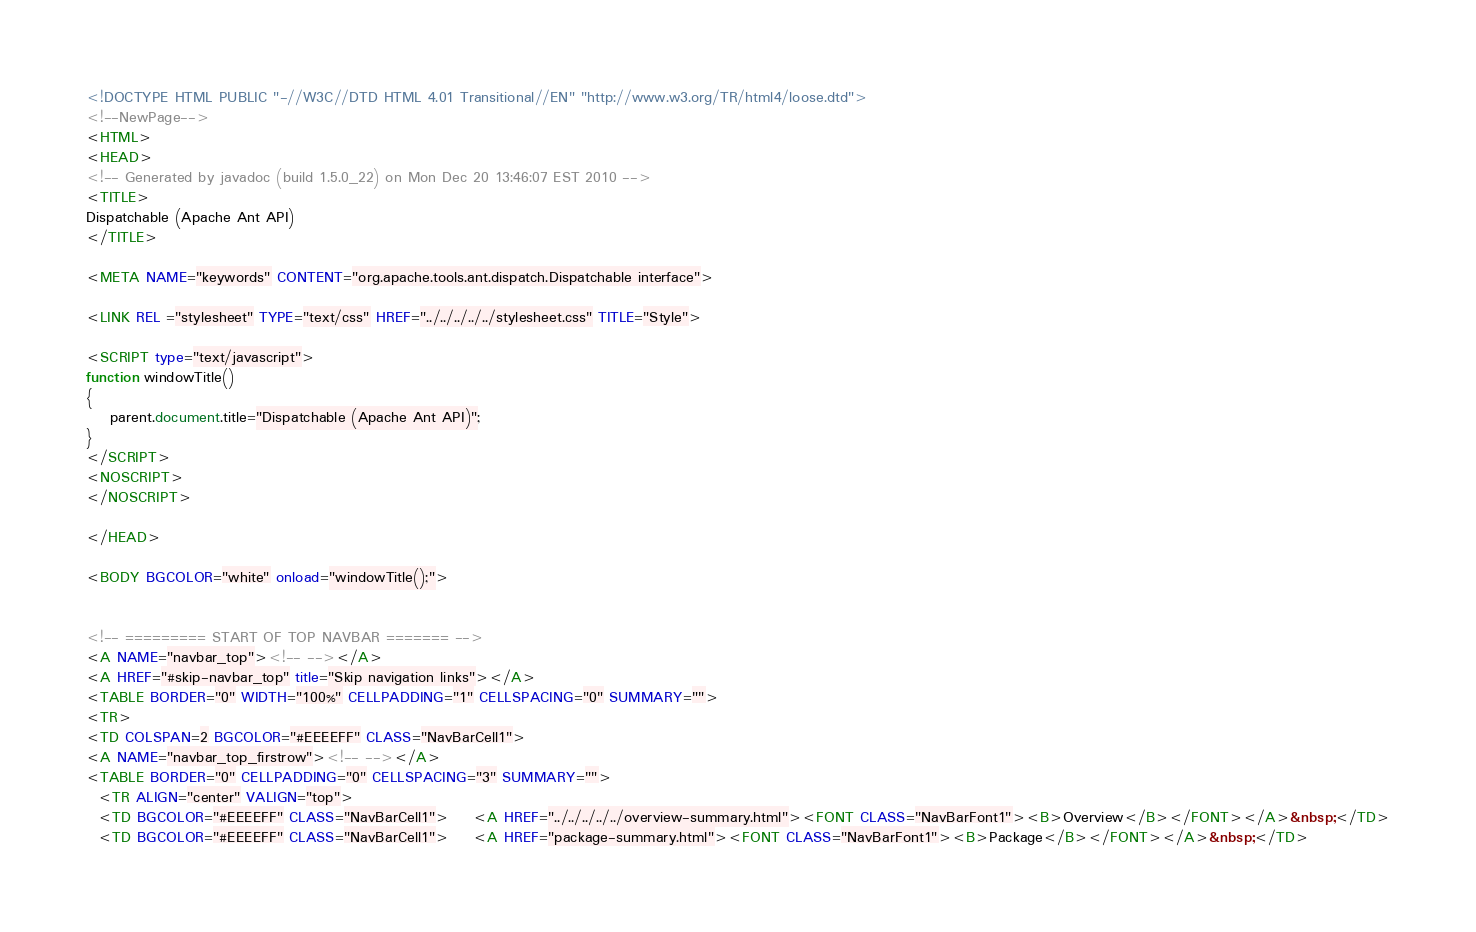Convert code to text. <code><loc_0><loc_0><loc_500><loc_500><_HTML_><!DOCTYPE HTML PUBLIC "-//W3C//DTD HTML 4.01 Transitional//EN" "http://www.w3.org/TR/html4/loose.dtd">
<!--NewPage-->
<HTML>
<HEAD>
<!-- Generated by javadoc (build 1.5.0_22) on Mon Dec 20 13:46:07 EST 2010 -->
<TITLE>
Dispatchable (Apache Ant API)
</TITLE>

<META NAME="keywords" CONTENT="org.apache.tools.ant.dispatch.Dispatchable interface">

<LINK REL ="stylesheet" TYPE="text/css" HREF="../../../../../stylesheet.css" TITLE="Style">

<SCRIPT type="text/javascript">
function windowTitle()
{
    parent.document.title="Dispatchable (Apache Ant API)";
}
</SCRIPT>
<NOSCRIPT>
</NOSCRIPT>

</HEAD>

<BODY BGCOLOR="white" onload="windowTitle();">


<!-- ========= START OF TOP NAVBAR ======= -->
<A NAME="navbar_top"><!-- --></A>
<A HREF="#skip-navbar_top" title="Skip navigation links"></A>
<TABLE BORDER="0" WIDTH="100%" CELLPADDING="1" CELLSPACING="0" SUMMARY="">
<TR>
<TD COLSPAN=2 BGCOLOR="#EEEEFF" CLASS="NavBarCell1">
<A NAME="navbar_top_firstrow"><!-- --></A>
<TABLE BORDER="0" CELLPADDING="0" CELLSPACING="3" SUMMARY="">
  <TR ALIGN="center" VALIGN="top">
  <TD BGCOLOR="#EEEEFF" CLASS="NavBarCell1">    <A HREF="../../../../../overview-summary.html"><FONT CLASS="NavBarFont1"><B>Overview</B></FONT></A>&nbsp;</TD>
  <TD BGCOLOR="#EEEEFF" CLASS="NavBarCell1">    <A HREF="package-summary.html"><FONT CLASS="NavBarFont1"><B>Package</B></FONT></A>&nbsp;</TD></code> 